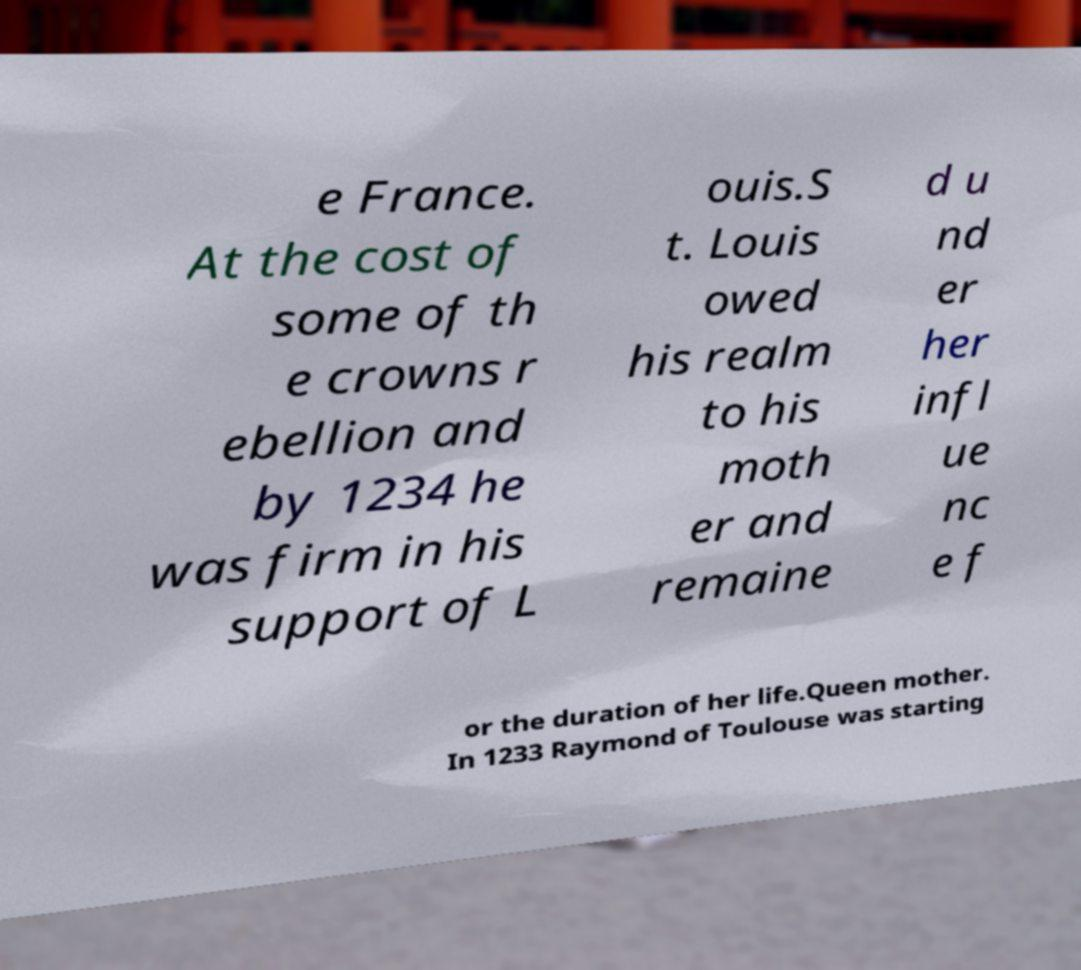There's text embedded in this image that I need extracted. Can you transcribe it verbatim? e France. At the cost of some of th e crowns r ebellion and by 1234 he was firm in his support of L ouis.S t. Louis owed his realm to his moth er and remaine d u nd er her infl ue nc e f or the duration of her life.Queen mother. In 1233 Raymond of Toulouse was starting 